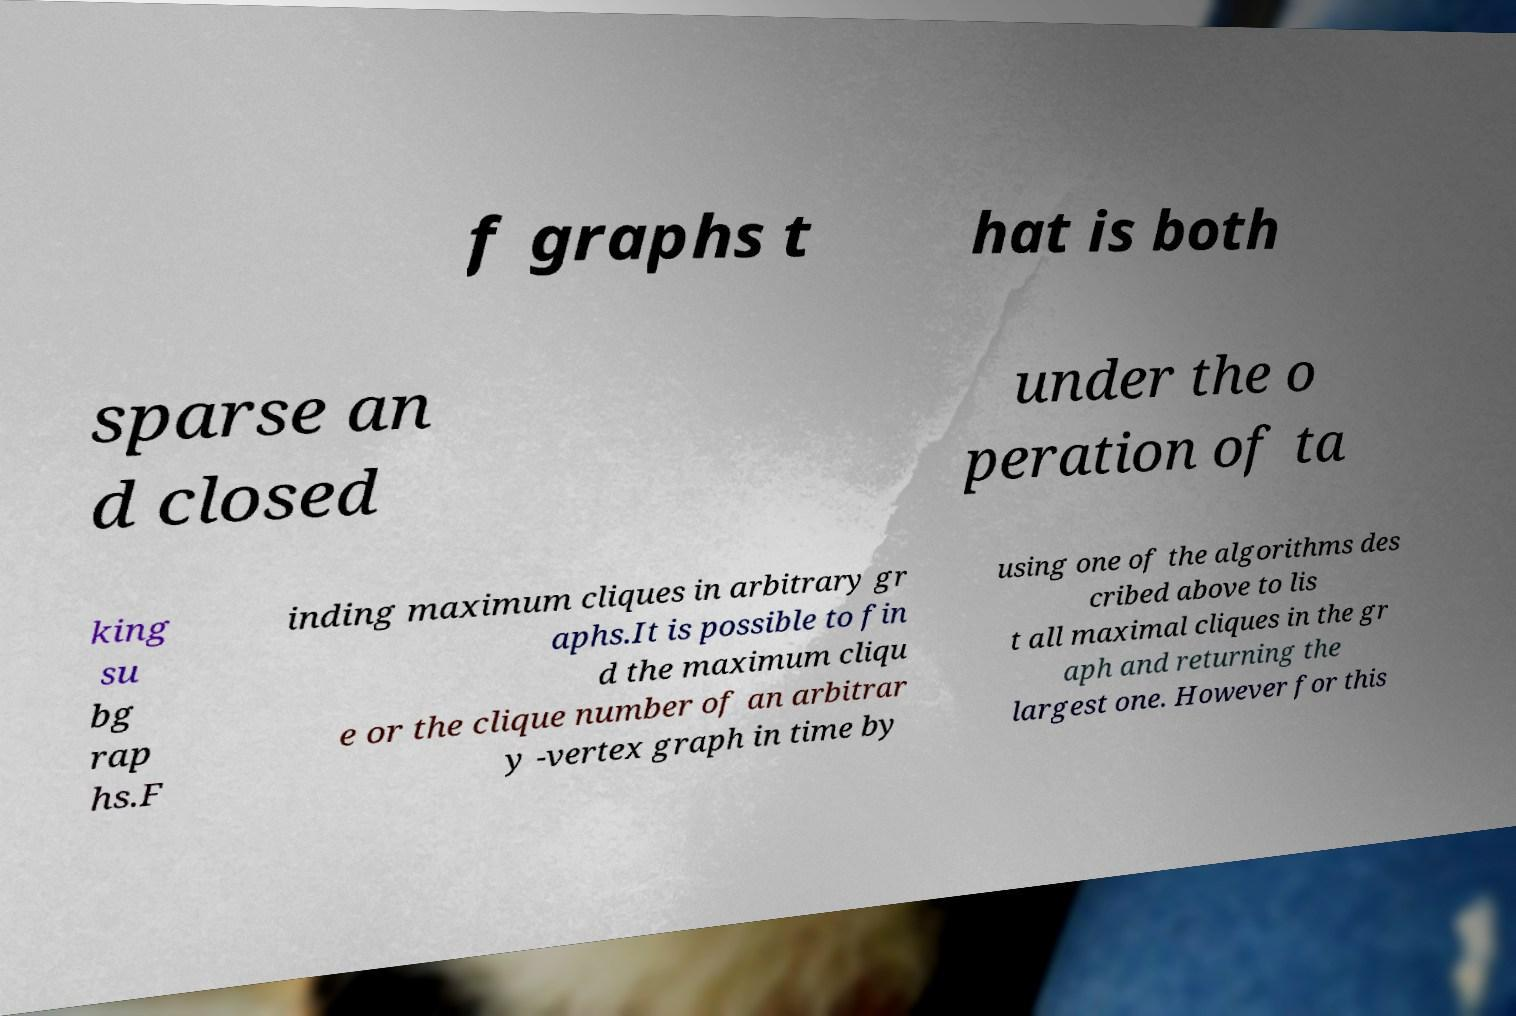Can you read and provide the text displayed in the image?This photo seems to have some interesting text. Can you extract and type it out for me? f graphs t hat is both sparse an d closed under the o peration of ta king su bg rap hs.F inding maximum cliques in arbitrary gr aphs.It is possible to fin d the maximum cliqu e or the clique number of an arbitrar y -vertex graph in time by using one of the algorithms des cribed above to lis t all maximal cliques in the gr aph and returning the largest one. However for this 